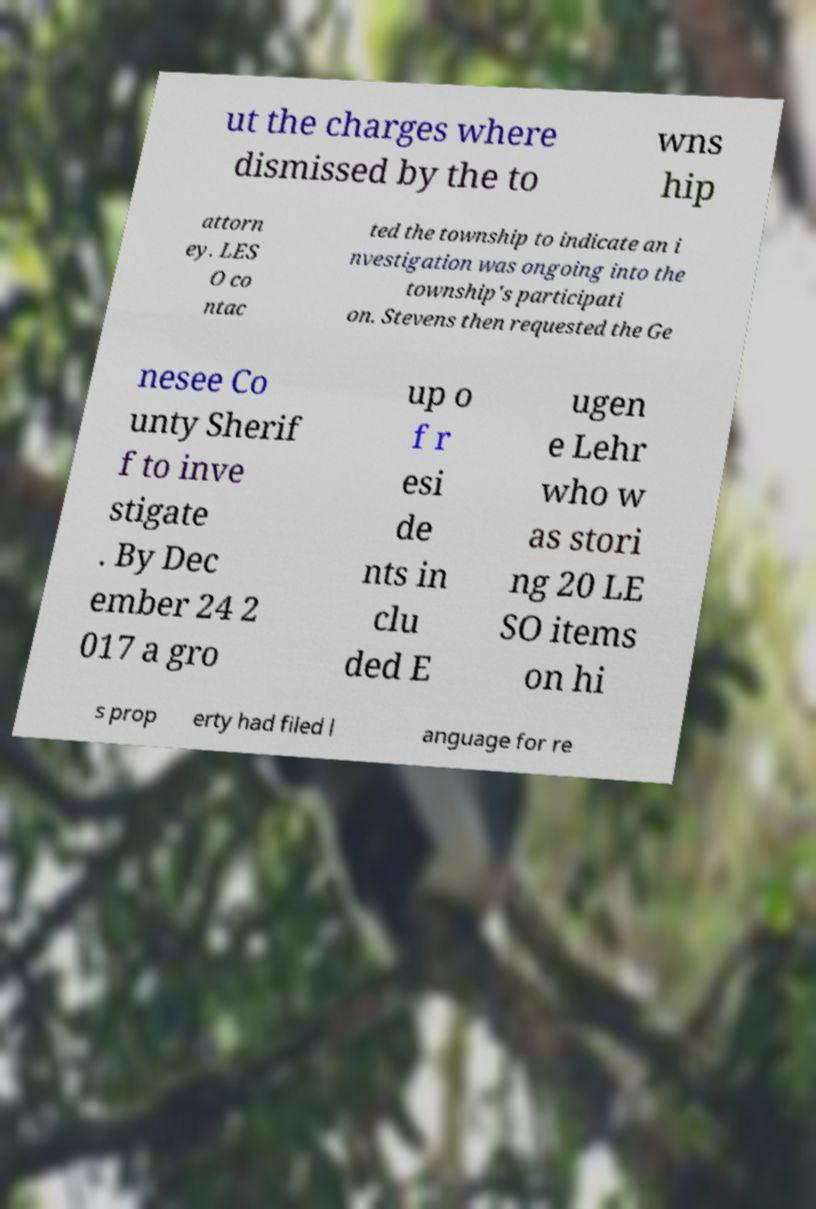Could you extract and type out the text from this image? ut the charges where dismissed by the to wns hip attorn ey. LES O co ntac ted the township to indicate an i nvestigation was ongoing into the township's participati on. Stevens then requested the Ge nesee Co unty Sherif f to inve stigate . By Dec ember 24 2 017 a gro up o f r esi de nts in clu ded E ugen e Lehr who w as stori ng 20 LE SO items on hi s prop erty had filed l anguage for re 